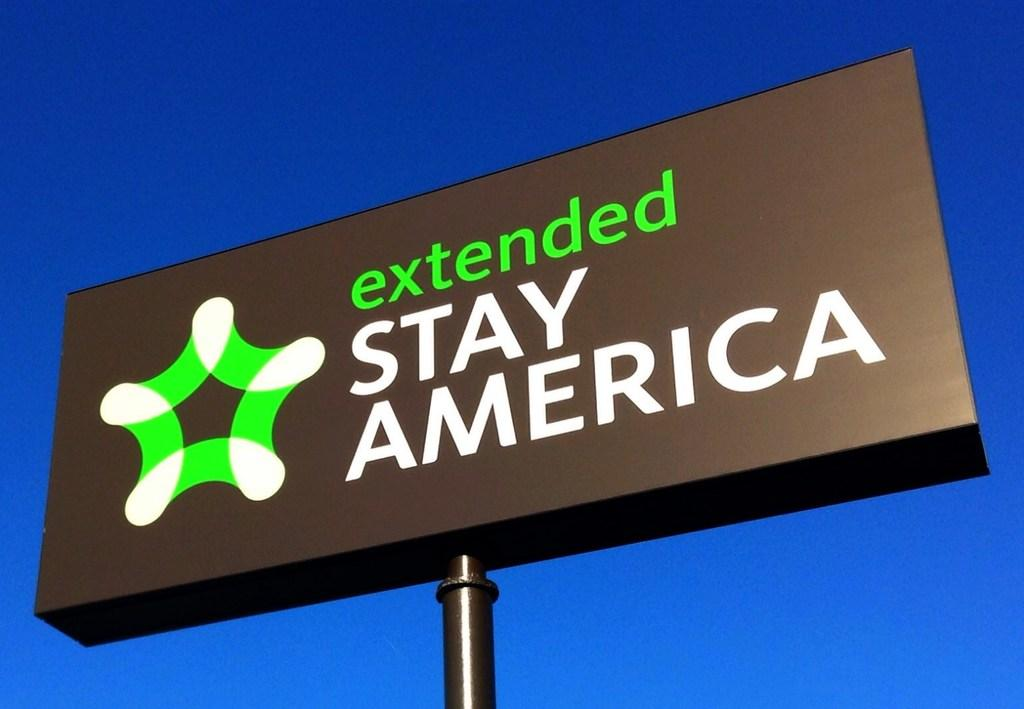<image>
Summarize the visual content of the image. A large billboard that says extended Stay America. 